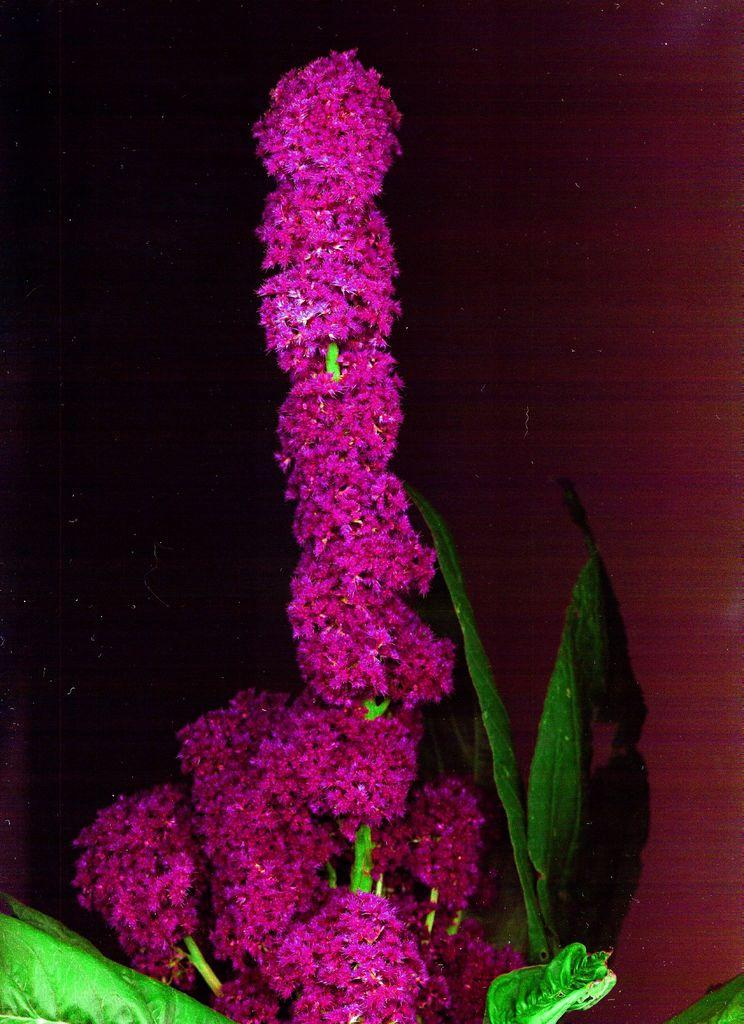What is the main subject of the image? There is a plant in the center of the image. Can you describe the plant in the image? Unfortunately, the provided facts do not include any details about the plant's appearance or characteristics. Is there anything else in the image besides the plant? The provided facts do not mention any other objects or subjects in the image. What month is depicted in the image? There is no month depicted in the image, as it features a plant in the center. What type of sign is present in the image? There is no sign present in the image, as it features a plant in the center. 